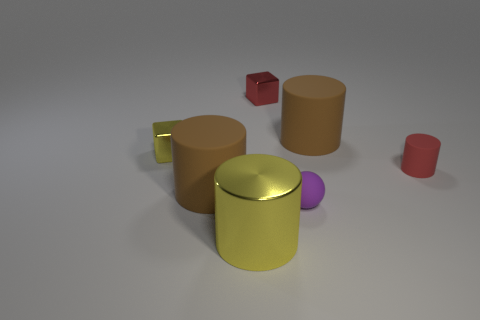The ball is what color?
Offer a terse response. Purple. What number of things are tiny balls in front of the yellow cube or big red metallic objects?
Offer a terse response. 1. There is a yellow shiny thing in front of the purple ball; is it the same size as the brown matte object that is to the right of the metal cylinder?
Give a very brief answer. Yes. How many objects are either big brown cylinders right of the large metal thing or tiny metal things that are right of the tiny yellow shiny cube?
Your response must be concise. 2. Do the small sphere and the big brown cylinder left of the red metallic thing have the same material?
Keep it short and to the point. Yes. What shape is the rubber thing that is in front of the small red matte thing and behind the small purple matte object?
Offer a terse response. Cylinder. What number of other things are there of the same color as the shiny cylinder?
Offer a very short reply. 1. What shape is the big metal thing?
Give a very brief answer. Cylinder. The small object that is to the right of the brown object right of the small purple matte ball is what color?
Offer a terse response. Red. There is a big metallic cylinder; does it have the same color as the shiny cube left of the big shiny cylinder?
Your response must be concise. Yes. 